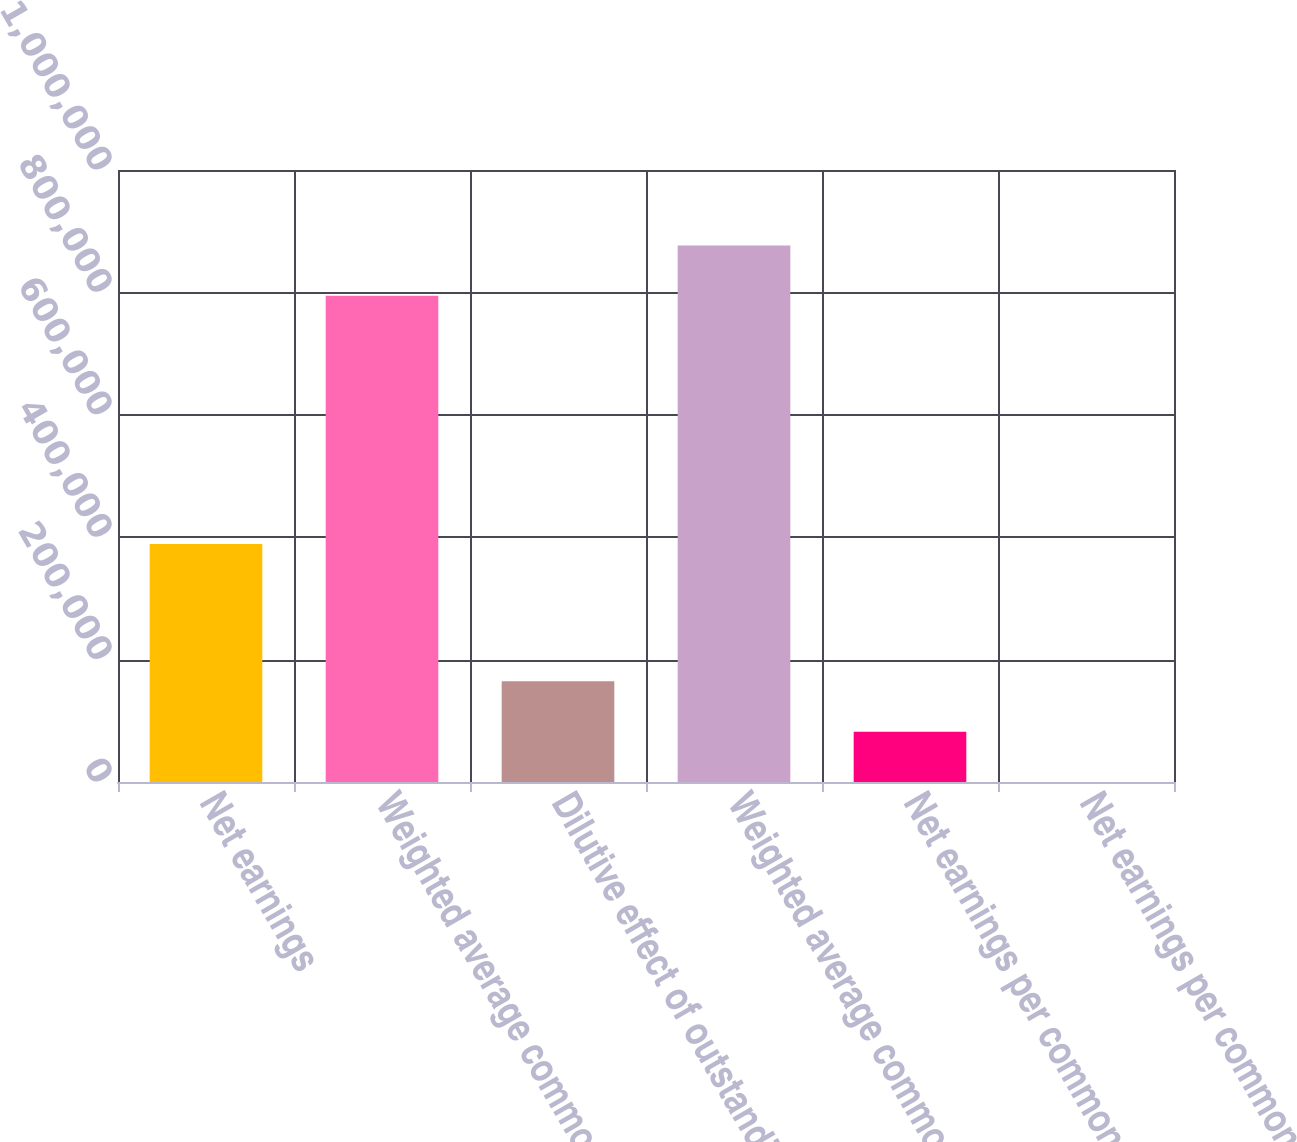Convert chart. <chart><loc_0><loc_0><loc_500><loc_500><bar_chart><fcel>Net earnings<fcel>Weighted average common shares<fcel>Dilutive effect of outstanding<fcel>Weighted average common and<fcel>Net earnings per common share<fcel>Net earnings per common and<nl><fcel>388880<fcel>794347<fcel>164586<fcel>876640<fcel>82293.4<fcel>0.47<nl></chart> 